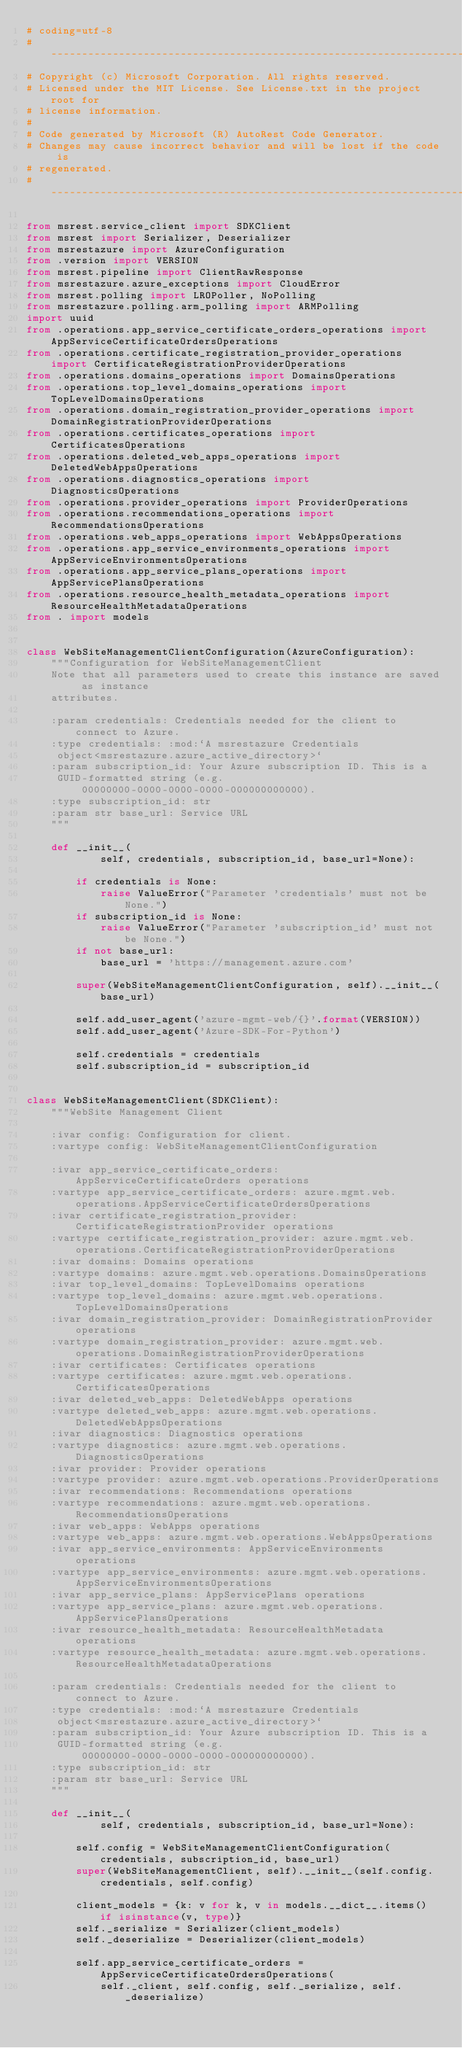<code> <loc_0><loc_0><loc_500><loc_500><_Python_># coding=utf-8
# --------------------------------------------------------------------------
# Copyright (c) Microsoft Corporation. All rights reserved.
# Licensed under the MIT License. See License.txt in the project root for
# license information.
#
# Code generated by Microsoft (R) AutoRest Code Generator.
# Changes may cause incorrect behavior and will be lost if the code is
# regenerated.
# --------------------------------------------------------------------------

from msrest.service_client import SDKClient
from msrest import Serializer, Deserializer
from msrestazure import AzureConfiguration
from .version import VERSION
from msrest.pipeline import ClientRawResponse
from msrestazure.azure_exceptions import CloudError
from msrest.polling import LROPoller, NoPolling
from msrestazure.polling.arm_polling import ARMPolling
import uuid
from .operations.app_service_certificate_orders_operations import AppServiceCertificateOrdersOperations
from .operations.certificate_registration_provider_operations import CertificateRegistrationProviderOperations
from .operations.domains_operations import DomainsOperations
from .operations.top_level_domains_operations import TopLevelDomainsOperations
from .operations.domain_registration_provider_operations import DomainRegistrationProviderOperations
from .operations.certificates_operations import CertificatesOperations
from .operations.deleted_web_apps_operations import DeletedWebAppsOperations
from .operations.diagnostics_operations import DiagnosticsOperations
from .operations.provider_operations import ProviderOperations
from .operations.recommendations_operations import RecommendationsOperations
from .operations.web_apps_operations import WebAppsOperations
from .operations.app_service_environments_operations import AppServiceEnvironmentsOperations
from .operations.app_service_plans_operations import AppServicePlansOperations
from .operations.resource_health_metadata_operations import ResourceHealthMetadataOperations
from . import models


class WebSiteManagementClientConfiguration(AzureConfiguration):
    """Configuration for WebSiteManagementClient
    Note that all parameters used to create this instance are saved as instance
    attributes.

    :param credentials: Credentials needed for the client to connect to Azure.
    :type credentials: :mod:`A msrestazure Credentials
     object<msrestazure.azure_active_directory>`
    :param subscription_id: Your Azure subscription ID. This is a
     GUID-formatted string (e.g. 00000000-0000-0000-0000-000000000000).
    :type subscription_id: str
    :param str base_url: Service URL
    """

    def __init__(
            self, credentials, subscription_id, base_url=None):

        if credentials is None:
            raise ValueError("Parameter 'credentials' must not be None.")
        if subscription_id is None:
            raise ValueError("Parameter 'subscription_id' must not be None.")
        if not base_url:
            base_url = 'https://management.azure.com'

        super(WebSiteManagementClientConfiguration, self).__init__(base_url)

        self.add_user_agent('azure-mgmt-web/{}'.format(VERSION))
        self.add_user_agent('Azure-SDK-For-Python')

        self.credentials = credentials
        self.subscription_id = subscription_id


class WebSiteManagementClient(SDKClient):
    """WebSite Management Client

    :ivar config: Configuration for client.
    :vartype config: WebSiteManagementClientConfiguration

    :ivar app_service_certificate_orders: AppServiceCertificateOrders operations
    :vartype app_service_certificate_orders: azure.mgmt.web.operations.AppServiceCertificateOrdersOperations
    :ivar certificate_registration_provider: CertificateRegistrationProvider operations
    :vartype certificate_registration_provider: azure.mgmt.web.operations.CertificateRegistrationProviderOperations
    :ivar domains: Domains operations
    :vartype domains: azure.mgmt.web.operations.DomainsOperations
    :ivar top_level_domains: TopLevelDomains operations
    :vartype top_level_domains: azure.mgmt.web.operations.TopLevelDomainsOperations
    :ivar domain_registration_provider: DomainRegistrationProvider operations
    :vartype domain_registration_provider: azure.mgmt.web.operations.DomainRegistrationProviderOperations
    :ivar certificates: Certificates operations
    :vartype certificates: azure.mgmt.web.operations.CertificatesOperations
    :ivar deleted_web_apps: DeletedWebApps operations
    :vartype deleted_web_apps: azure.mgmt.web.operations.DeletedWebAppsOperations
    :ivar diagnostics: Diagnostics operations
    :vartype diagnostics: azure.mgmt.web.operations.DiagnosticsOperations
    :ivar provider: Provider operations
    :vartype provider: azure.mgmt.web.operations.ProviderOperations
    :ivar recommendations: Recommendations operations
    :vartype recommendations: azure.mgmt.web.operations.RecommendationsOperations
    :ivar web_apps: WebApps operations
    :vartype web_apps: azure.mgmt.web.operations.WebAppsOperations
    :ivar app_service_environments: AppServiceEnvironments operations
    :vartype app_service_environments: azure.mgmt.web.operations.AppServiceEnvironmentsOperations
    :ivar app_service_plans: AppServicePlans operations
    :vartype app_service_plans: azure.mgmt.web.operations.AppServicePlansOperations
    :ivar resource_health_metadata: ResourceHealthMetadata operations
    :vartype resource_health_metadata: azure.mgmt.web.operations.ResourceHealthMetadataOperations

    :param credentials: Credentials needed for the client to connect to Azure.
    :type credentials: :mod:`A msrestazure Credentials
     object<msrestazure.azure_active_directory>`
    :param subscription_id: Your Azure subscription ID. This is a
     GUID-formatted string (e.g. 00000000-0000-0000-0000-000000000000).
    :type subscription_id: str
    :param str base_url: Service URL
    """

    def __init__(
            self, credentials, subscription_id, base_url=None):

        self.config = WebSiteManagementClientConfiguration(credentials, subscription_id, base_url)
        super(WebSiteManagementClient, self).__init__(self.config.credentials, self.config)

        client_models = {k: v for k, v in models.__dict__.items() if isinstance(v, type)}
        self._serialize = Serializer(client_models)
        self._deserialize = Deserializer(client_models)

        self.app_service_certificate_orders = AppServiceCertificateOrdersOperations(
            self._client, self.config, self._serialize, self._deserialize)</code> 